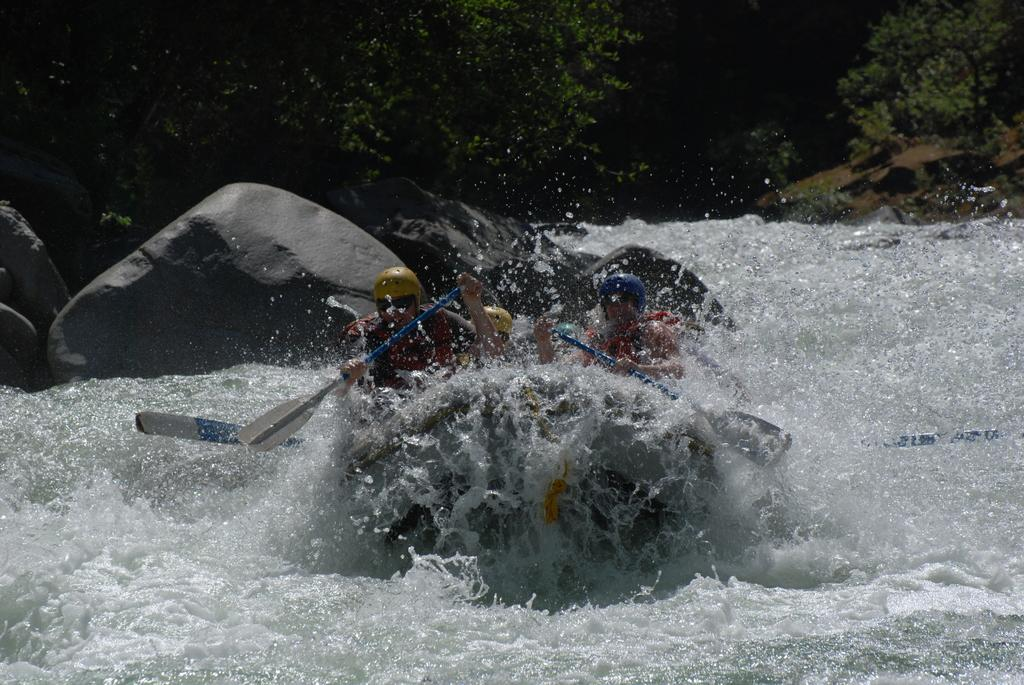What is the main subject of the image? The main subject of the image is a boat. Where is the boat located? The boat is on the water. What are the persons on the boat doing? The persons on the boat are holding paddles. What can be seen in the background of the image? There are rocks and trees in the background of the image. What type of form does the woman in the image have? There is no woman present in the image; it features a boat on the water with persons holding paddles. 